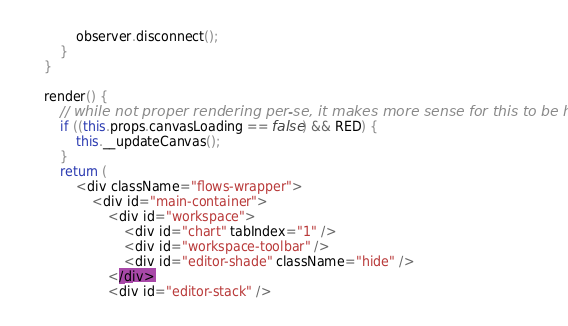Convert code to text. <code><loc_0><loc_0><loc_500><loc_500><_JavaScript_>            observer.disconnect();
        }
    }

    render() {
        // while not proper rendering per-se, it makes more sense for this to be here
        if ((this.props.canvasLoading == false) && RED) {
            this.__updateCanvas();
        }
        return (
            <div className="flows-wrapper">
                <div id="main-container">
                    <div id="workspace">
                        <div id="chart" tabIndex="1" />
                        <div id="workspace-toolbar" />
                        <div id="editor-shade" className="hide" />
                    </div>
                    <div id="editor-stack" />
</code> 